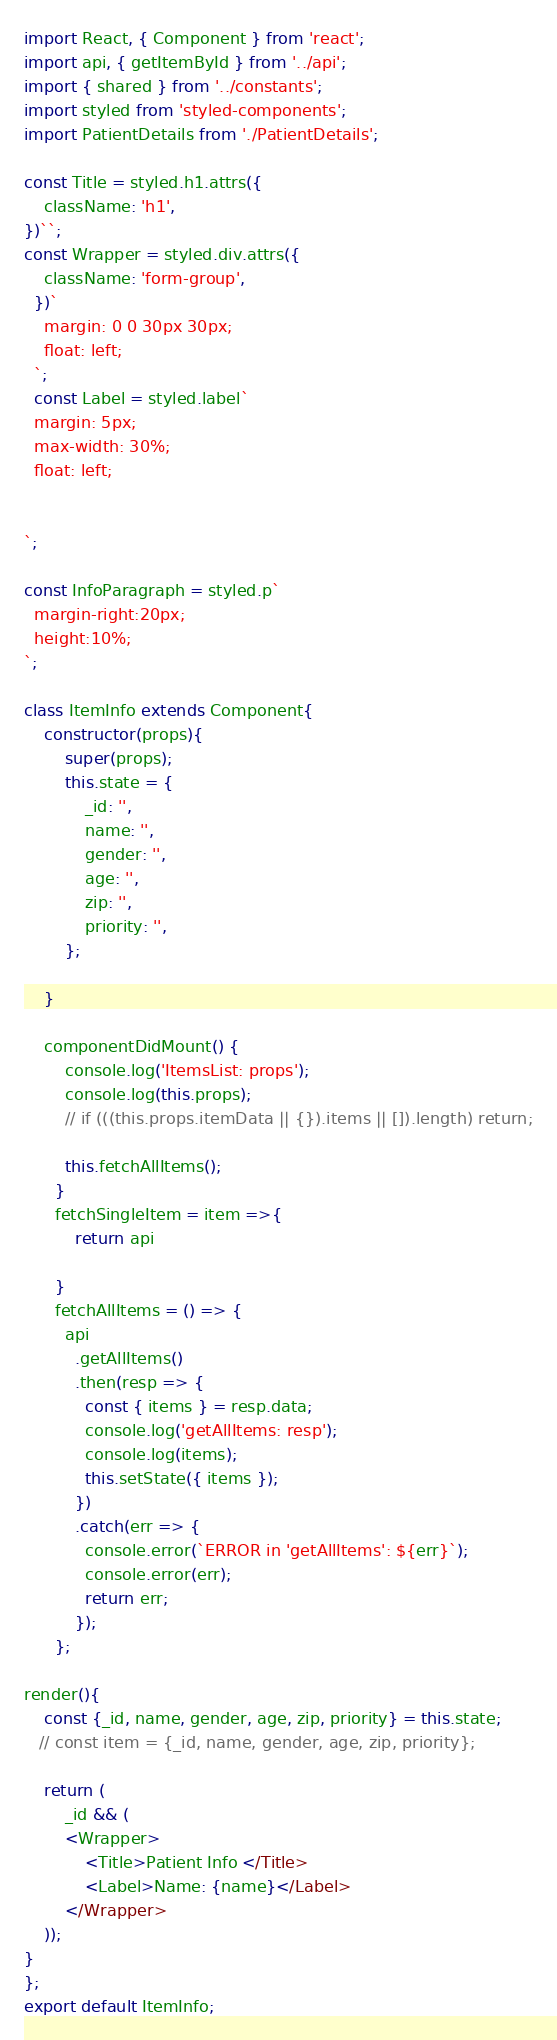Convert code to text. <code><loc_0><loc_0><loc_500><loc_500><_JavaScript_>import React, { Component } from 'react';
import api, { getItemById } from '../api';
import { shared } from '../constants';
import styled from 'styled-components';
import PatientDetails from './PatientDetails';

const Title = styled.h1.attrs({
    className: 'h1',
})``;
const Wrapper = styled.div.attrs({
    className: 'form-group',
  })`
    margin: 0 0 30px 30px;
    float: left;
  `;
  const Label = styled.label`
  margin: 5px;
  max-width: 30%;
  float: left;
  

`;

const InfoParagraph = styled.p`
  margin-right:20px;
  height:10%;
`;
  
class ItemInfo extends Component{
    constructor(props){
        super(props);
        this.state = {
            _id: '',
            name: '',
            gender: '',
            age: '',
            zip: '',
            priority: '',
        };
       
    }

    componentDidMount() {
        console.log('ItemsList: props');
        console.log(this.props);
        // if (((this.props.itemData || {}).items || []).length) return;
    
        this.fetchAllItems();
      }
      fetchSingleItem = item =>{
          return api
          
      }
      fetchAllItems = () => {
        api
          .getAllItems()
          .then(resp => {
            const { items } = resp.data;
            console.log('getAllItems: resp');
            console.log(items);
            this.setState({ items });
          })
          .catch(err => {
            console.error(`ERROR in 'getAllItems': ${err}`);
            console.error(err);
            return err;
          });
      };

render(){
    const {_id, name, gender, age, zip, priority} = this.state;
   // const item = {_id, name, gender, age, zip, priority};

    return (
        _id && (
        <Wrapper>
            <Title>Patient Info </Title>
            <Label>Name: {name}</Label>
        </Wrapper>
    ));
}
};
export default ItemInfo;</code> 